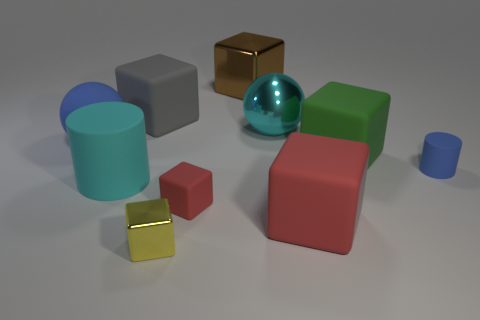Subtract all big brown shiny cubes. How many cubes are left? 5 Subtract all gray blocks. How many blocks are left? 5 Subtract all yellow blocks. Subtract all gray cylinders. How many blocks are left? 5 Subtract all red cylinders. How many blue cubes are left? 0 Subtract all large cyan metallic things. Subtract all big cyan matte cylinders. How many objects are left? 8 Add 9 large cyan rubber cylinders. How many large cyan rubber cylinders are left? 10 Add 9 tiny shiny cubes. How many tiny shiny cubes exist? 10 Subtract 0 brown cylinders. How many objects are left? 10 Subtract all cylinders. How many objects are left? 8 Subtract 4 blocks. How many blocks are left? 2 